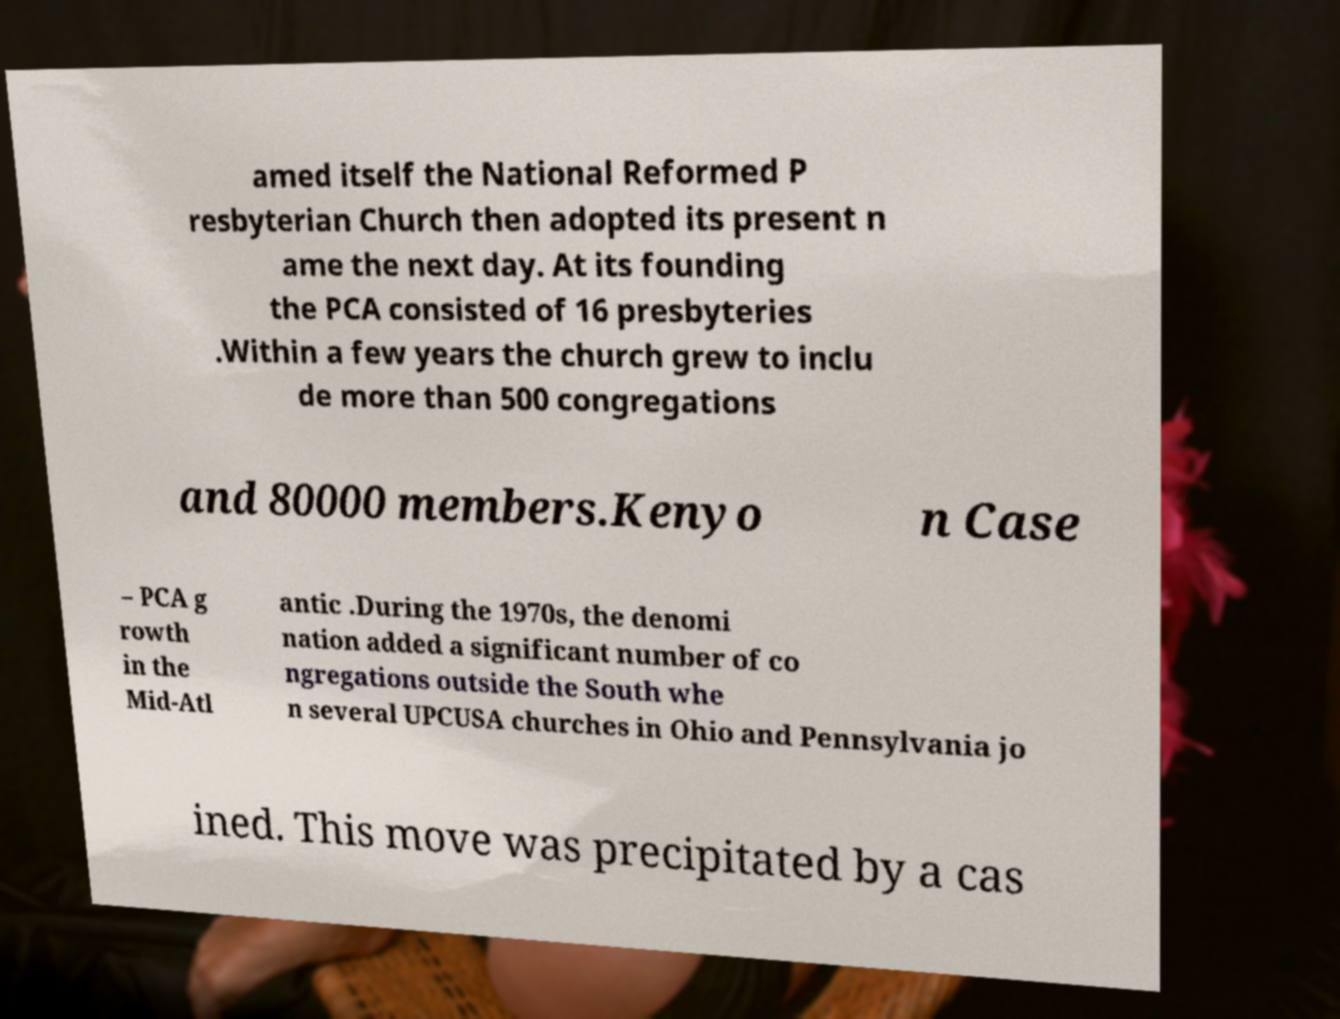Please identify and transcribe the text found in this image. amed itself the National Reformed P resbyterian Church then adopted its present n ame the next day. At its founding the PCA consisted of 16 presbyteries .Within a few years the church grew to inclu de more than 500 congregations and 80000 members.Kenyo n Case – PCA g rowth in the Mid-Atl antic .During the 1970s, the denomi nation added a significant number of co ngregations outside the South whe n several UPCUSA churches in Ohio and Pennsylvania jo ined. This move was precipitated by a cas 